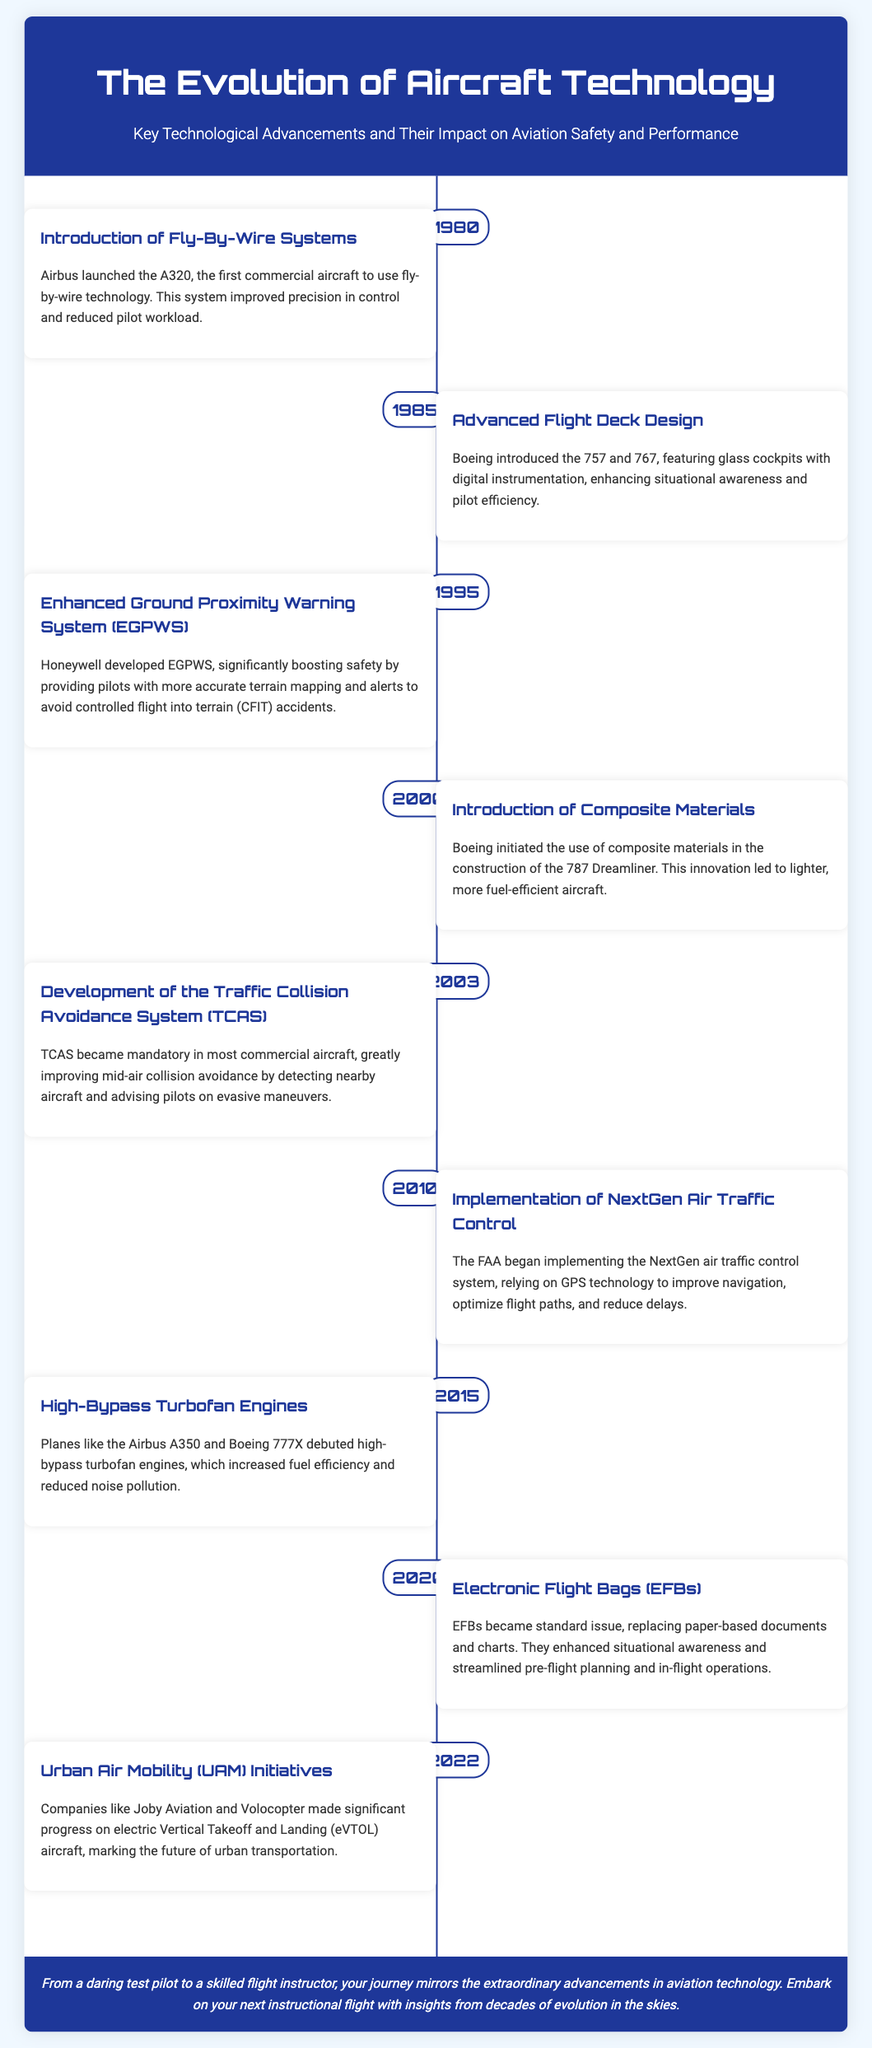What year was fly-by-wire technology introduced? Fly-by-wire technology was introduced in 1980 with the launch of the Airbus A320.
Answer: 1980 Which company developed the Enhanced Ground Proximity Warning System? The Enhanced Ground Proximity Warning System was developed by Honeywell.
Answer: Honeywell What significant material was introduced in the construction of the 787 Dreamliner? The 787 Dreamliner introduced composite materials for aircraft construction.
Answer: Composite materials What is the main purpose of the Traffic Collision Avoidance System (TCAS)? TCAS aims to improve mid-air collision avoidance by advising pilots on evasive maneuvers.
Answer: Mid-air collision avoidance Which system began its implementation in 2010? The NextGen air traffic control system began implementation in 2010.
Answer: NextGen air traffic control system What aviation technology became standard issue in 2020? Electronic Flight Bags (EFBs) became standard issue in 2020.
Answer: Electronic Flight Bags (EFBs) Which aircraft debuted high-bypass turbofan engines in 2015? The Airbus A350 and Boeing 777X debuted high-bypass turbofan engines in 2015.
Answer: Airbus A350 and Boeing 777X How did advanced flight deck design enhance pilot efficiency? Advanced flight deck design enhanced situational awareness and pilot efficiency through digital instrumentation.
Answer: Digital instrumentation What transportation future was marked by UAM initiatives in 2022? Urban Air Mobility (UAM) initiatives marked the future of urban transportation in 2022.
Answer: Urban Air Mobility (UAM) initiatives 